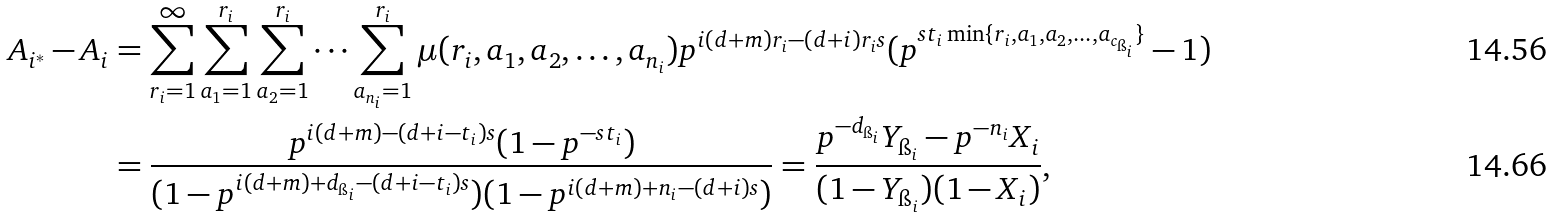Convert formula to latex. <formula><loc_0><loc_0><loc_500><loc_500>A _ { i ^ { * } } - A _ { i } & = \sum _ { r _ { i } = 1 } ^ { \infty } \sum _ { a _ { 1 } = 1 } ^ { r _ { i } } \sum _ { a _ { 2 } = 1 } ^ { r _ { i } } \dots \sum _ { a _ { n _ { i } } = 1 } ^ { r _ { i } } \mu ( r _ { i } , a _ { 1 } , a _ { 2 } , \dots , a _ { n _ { i } } ) p ^ { i ( d + m ) r _ { i } - { ( d + i ) r _ { i } } s } ( p ^ { s t _ { i } \min \{ r _ { i } , a _ { 1 } , a _ { 2 } , \dots , a _ { c _ { \i _ { i } } } \} } - 1 ) \\ & = \frac { p ^ { i ( d + m ) - ( d + i - t _ { i } ) s } ( 1 - p ^ { - s t _ { i } } ) } { ( 1 - p ^ { i ( d + m ) + d _ { \i _ { i } } - ( d + i - t _ { i } ) s } ) ( 1 - p ^ { i ( d + m ) + n _ { i } - ( { d + i } ) s } ) } = \frac { p ^ { - d _ { \i _ { i } } } Y _ { \i _ { i } } - p ^ { - n _ { i } } X _ { i } } { ( 1 - Y _ { \i _ { i } } ) ( 1 - X _ { i } ) } ,</formula> 